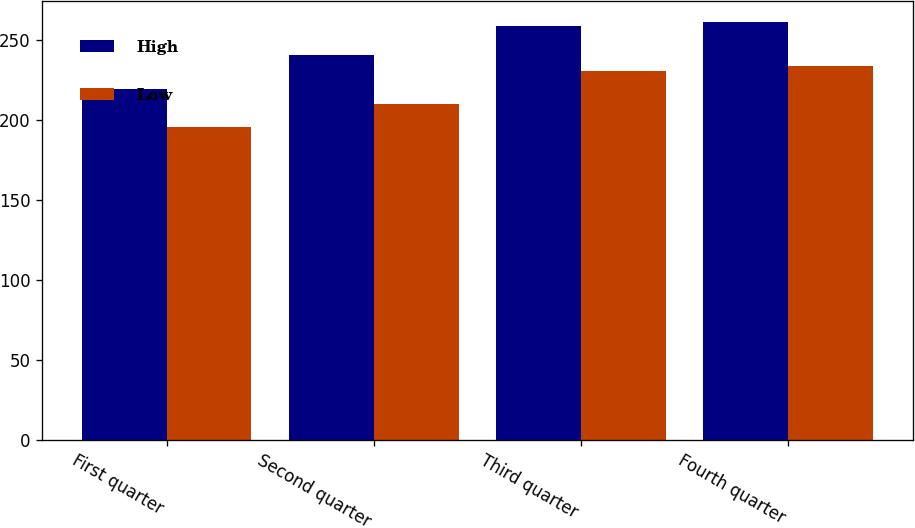Convert chart to OTSL. <chart><loc_0><loc_0><loc_500><loc_500><stacked_bar_chart><ecel><fcel>First quarter<fcel>Second quarter<fcel>Third quarter<fcel>Fourth quarter<nl><fcel>High<fcel>219.25<fcel>240.62<fcel>258.75<fcel>260.86<nl><fcel>Low<fcel>195.24<fcel>209.77<fcel>230.77<fcel>233.28<nl></chart> 